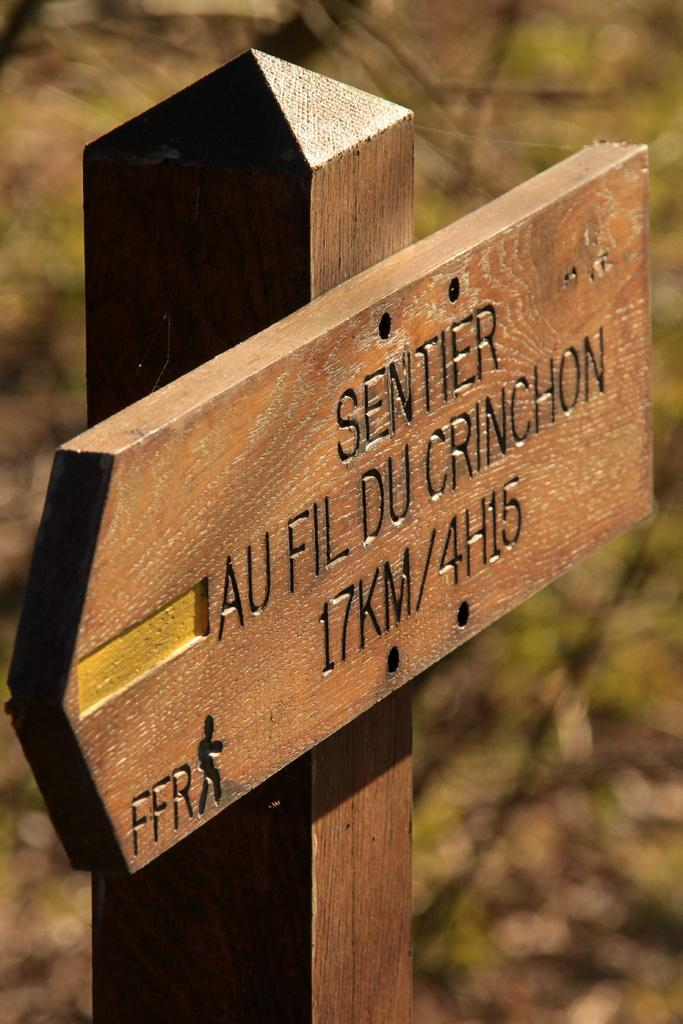What is the main object in the image? There is a wooden board in the image. How is the wooden board positioned? The wooden board is attached to a wooden pole. What can be observed about the background of the image? The background of the image is blurred. What is written on the wooden board? There is writing on the wooden board. Can you see any rays of water coming from the wooden board in the image? There are no rays of water present in the image; it features a wooden board attached to a wooden pole with writing on it. Are there any fowl visible in the image? There are no fowl present in the image. 